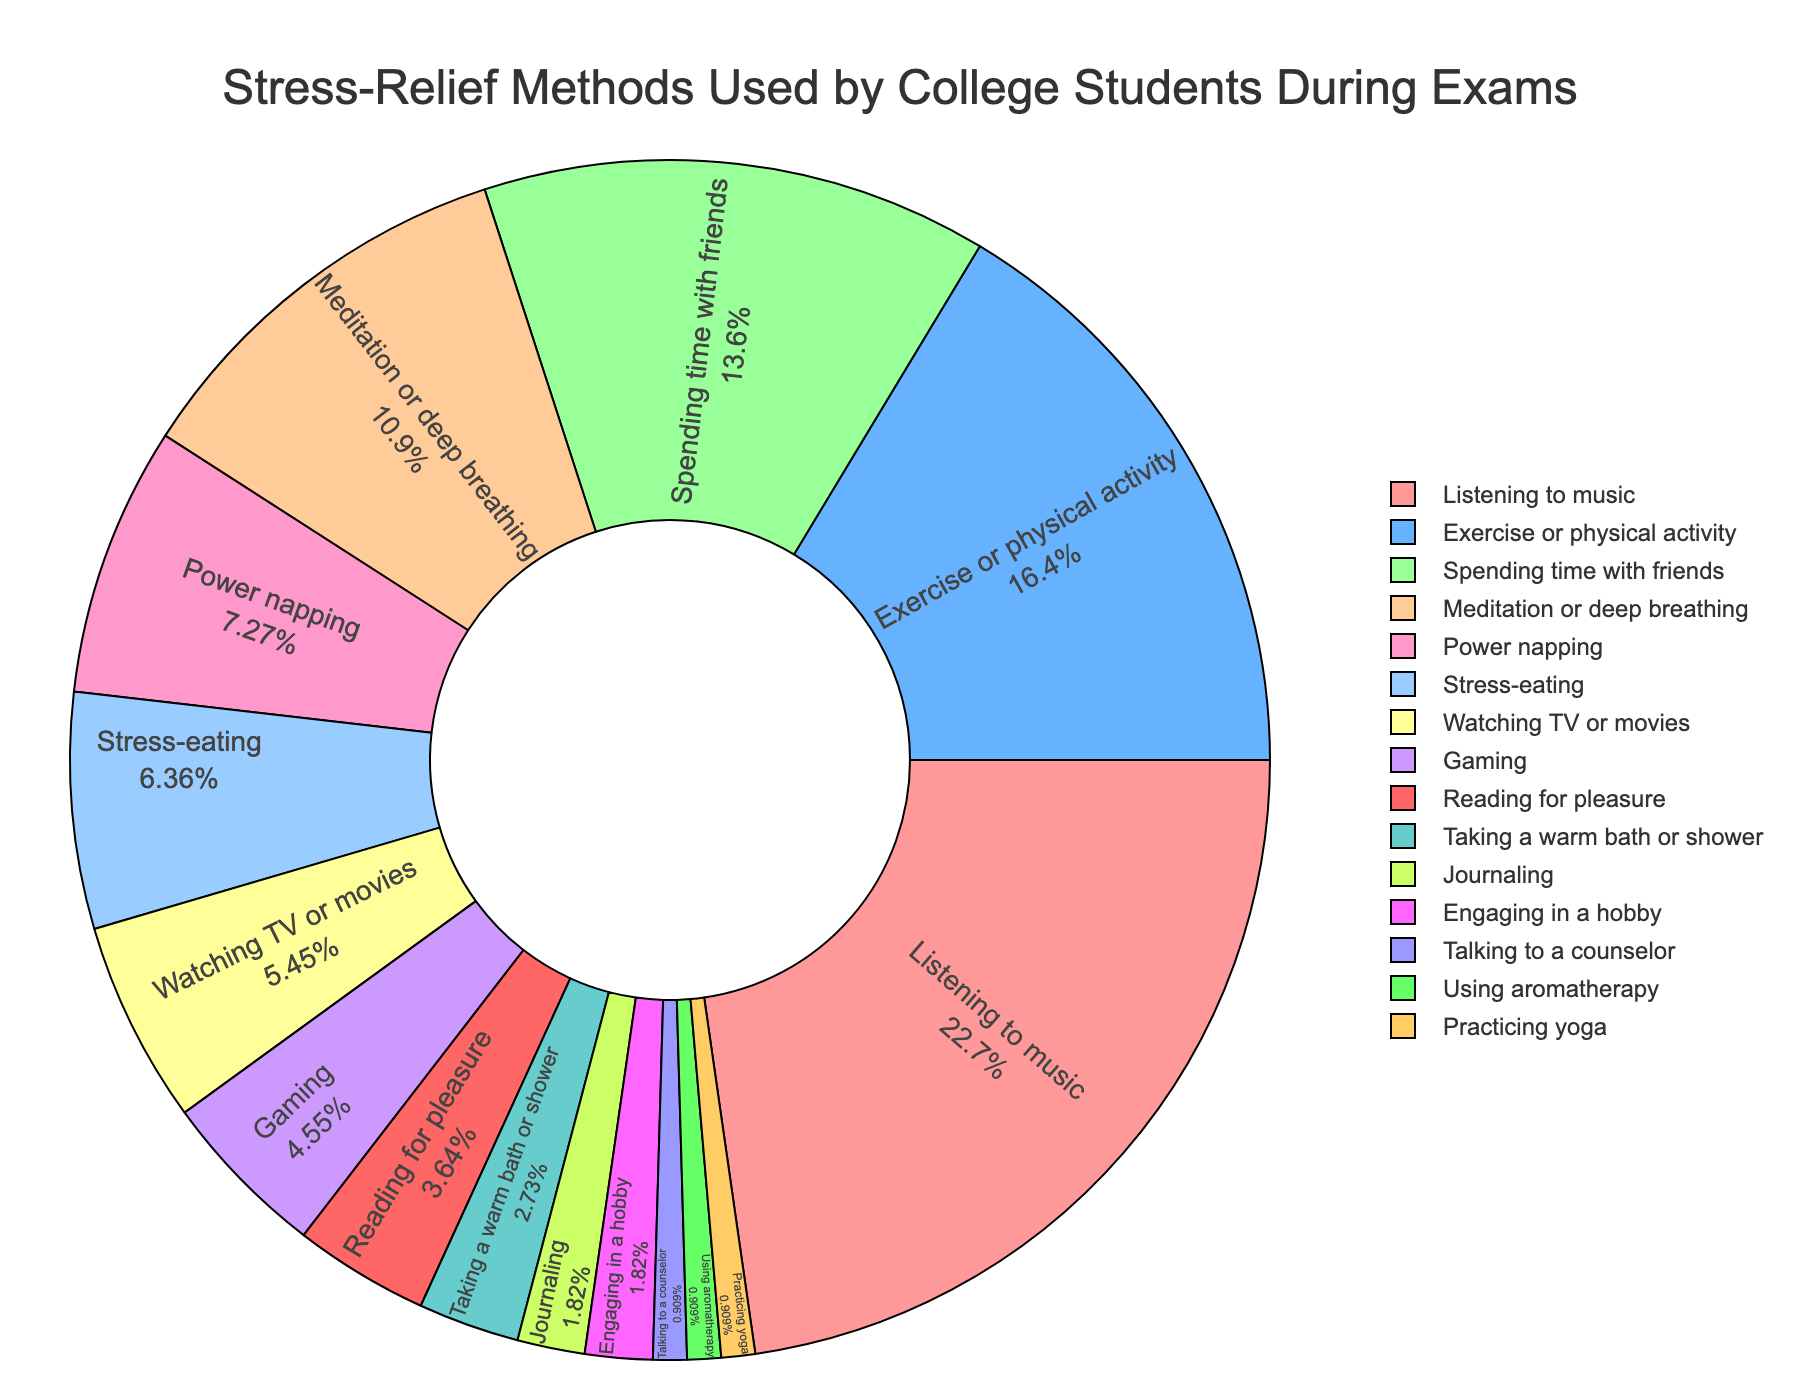What is the most common stress-relief method used by college students during exam periods? The most common method is the one with the largest percentage. By looking at the pie chart, we see that "Listening to music" has the highest percentage (25%).
Answer: Listening to music Which stress-relief methods have the same percentage usage? To find this, we look for slices in the pie chart that have the same size or the same percentage label. "Journaling", "Engaging in a hobby", and "Practicing yoga" each have a 2% usage. Additionally, "Talking to a counselor" and "Using aromatherapy" each have a 1% usage.
Answer: Journaling, Engaging in a hobby, Practicing yoga; Talking to a counselor, Using aromatherapy What percentage of students use either "Exercise or physical activity" or "Spending time with friends" as stress-relief methods? Sum the percentages of "Exercise or physical activity" (18%) and "Spending time with friends" (15%). 18 + 15 = 33
Answer: 33% Which stress-relief method category is smaller: "Watching TV or movies" or "Gaming"? Compare the percentages of "Watching TV or movies" (6%) and "Gaming" (5%). "Gaming" has a smaller percentage.
Answer: Gaming How much more popular is "Listening to music" compared to "Meditation or deep breathing"? Subtract the percentage of "Meditation or deep breathing" (12%) from "Listening to music" (25%). 25 - 12 = 13
Answer: 13% What is the percentage of students who engage in activities that involve either being with themselves (like "Meditation or deep breathing", "Power napping", "Taking a warm bath or shower", "Journaling", "Engaging in a hobby", "Practicing yoga")? Sum the percentages: 12 (Meditation or deep breathing) + 8 (Power napping) + 3 (Taking a warm bath or shower) + 2 (Journaling) + 2 (Engaging in a hobby) + 1 (Practicing yoga). 12 + 8 + 3 + 2 + 2 + 1 = 28
Answer: 28% Are there more students using "Stress-eating" or "Gaming" as a stress-relief method? Compare the percentages. "Stress-eating" has 7% while "Gaming" has 5%. More students use "Stress-eating".
Answer: Stress-eating Which method has a smaller percentage: "Talking to a counselor" or "Using aromatherapy"? Compare their percentages. Both "Talking to a counselor" and "Using aromatherapy" have 1%, so neither has a smaller percentage; they are equal.
Answer: Equal What is the combined percentage of the three least common stress-relief methods? Identify the three methods with the smallest percentages: "Talking to a counselor" (1%), "Using aromatherapy" (1%), and "Practicing yoga" (1%). Sum these: 1 + 1 + 1 = 3
Answer: 3% What is the difference in percentage points between the stress-relief method with the highest percentage and the one with the lowest percentage? Look at the highest percentage (25% for "Listening to music") and the lowest percentages (1% each for "Talking to a counselor", "Using aromatherapy", and "Practicing yoga"). Subtract the smallest from the largest: 25 - 1 = 24
Answer: 24 